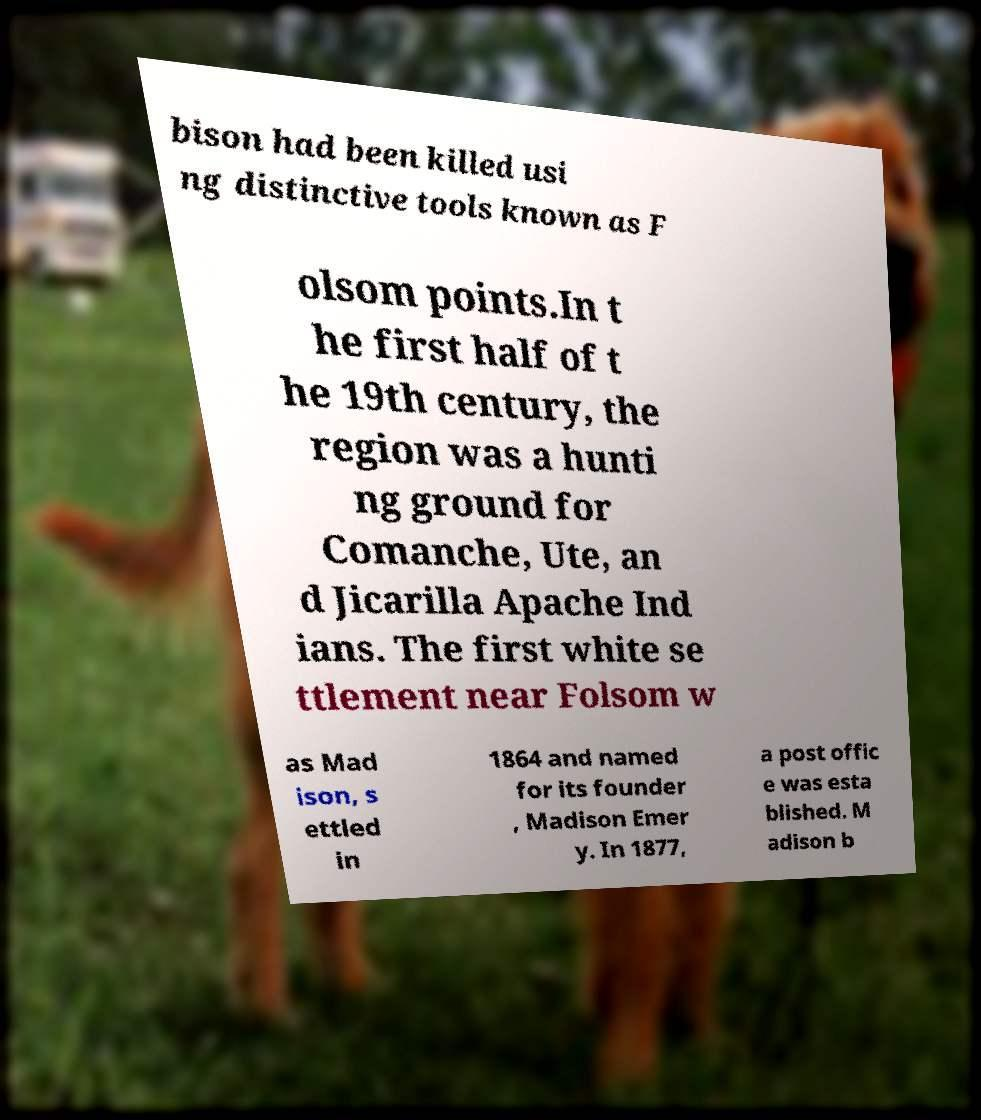Can you accurately transcribe the text from the provided image for me? bison had been killed usi ng distinctive tools known as F olsom points.In t he first half of t he 19th century, the region was a hunti ng ground for Comanche, Ute, an d Jicarilla Apache Ind ians. The first white se ttlement near Folsom w as Mad ison, s ettled in 1864 and named for its founder , Madison Emer y. In 1877, a post offic e was esta blished. M adison b 